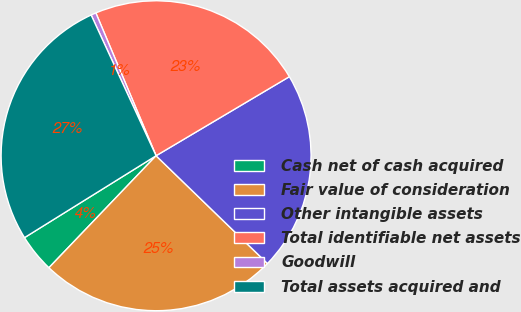<chart> <loc_0><loc_0><loc_500><loc_500><pie_chart><fcel>Cash net of cash acquired<fcel>Fair value of consideration<fcel>Other intangible assets<fcel>Total identifiable net assets<fcel>Goodwill<fcel>Total assets acquired and<nl><fcel>3.99%<fcel>24.91%<fcel>20.76%<fcel>22.83%<fcel>0.53%<fcel>26.98%<nl></chart> 